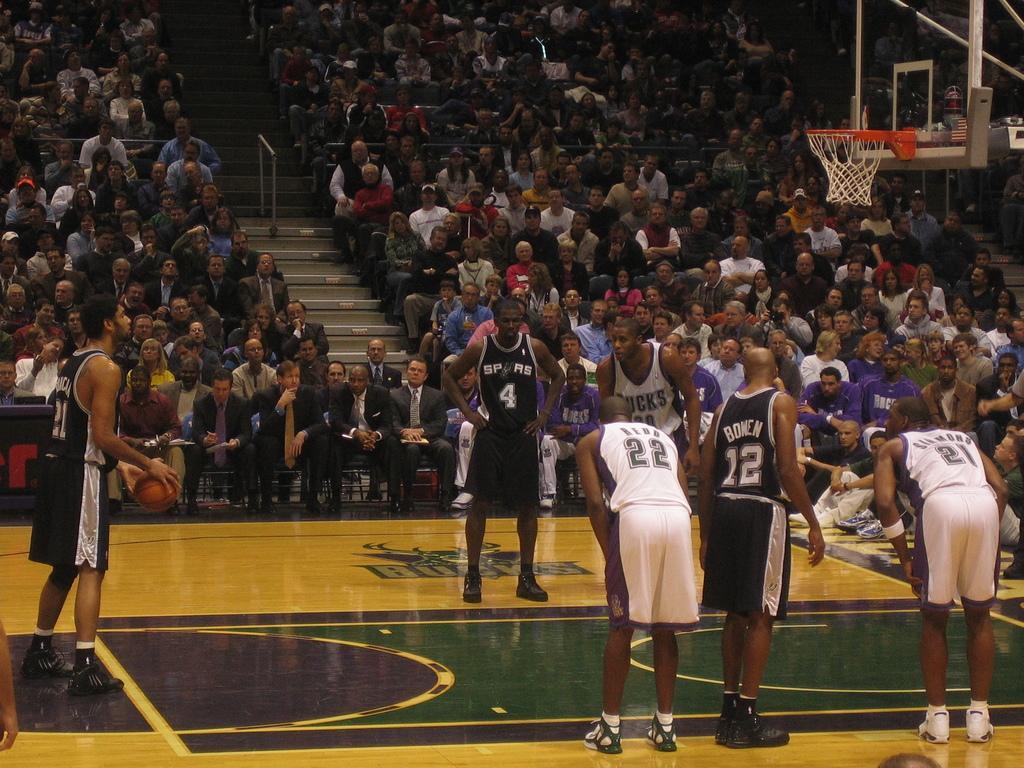Describe this image in one or two sentences. In this there are basketball players in the center of the image and there are group of people in the background area of the image as audience. 